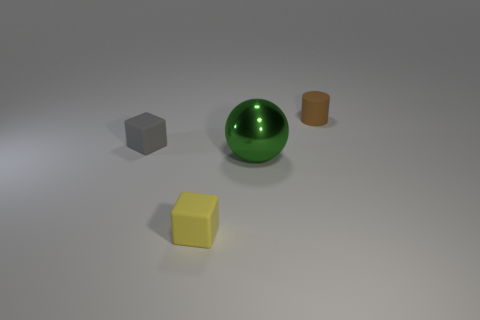Add 1 small things. How many objects exist? 5 Subtract all cylinders. How many objects are left? 3 Add 2 big green balls. How many big green balls are left? 3 Add 2 big red blocks. How many big red blocks exist? 2 Subtract 0 cyan spheres. How many objects are left? 4 Subtract all gray objects. Subtract all yellow cubes. How many objects are left? 2 